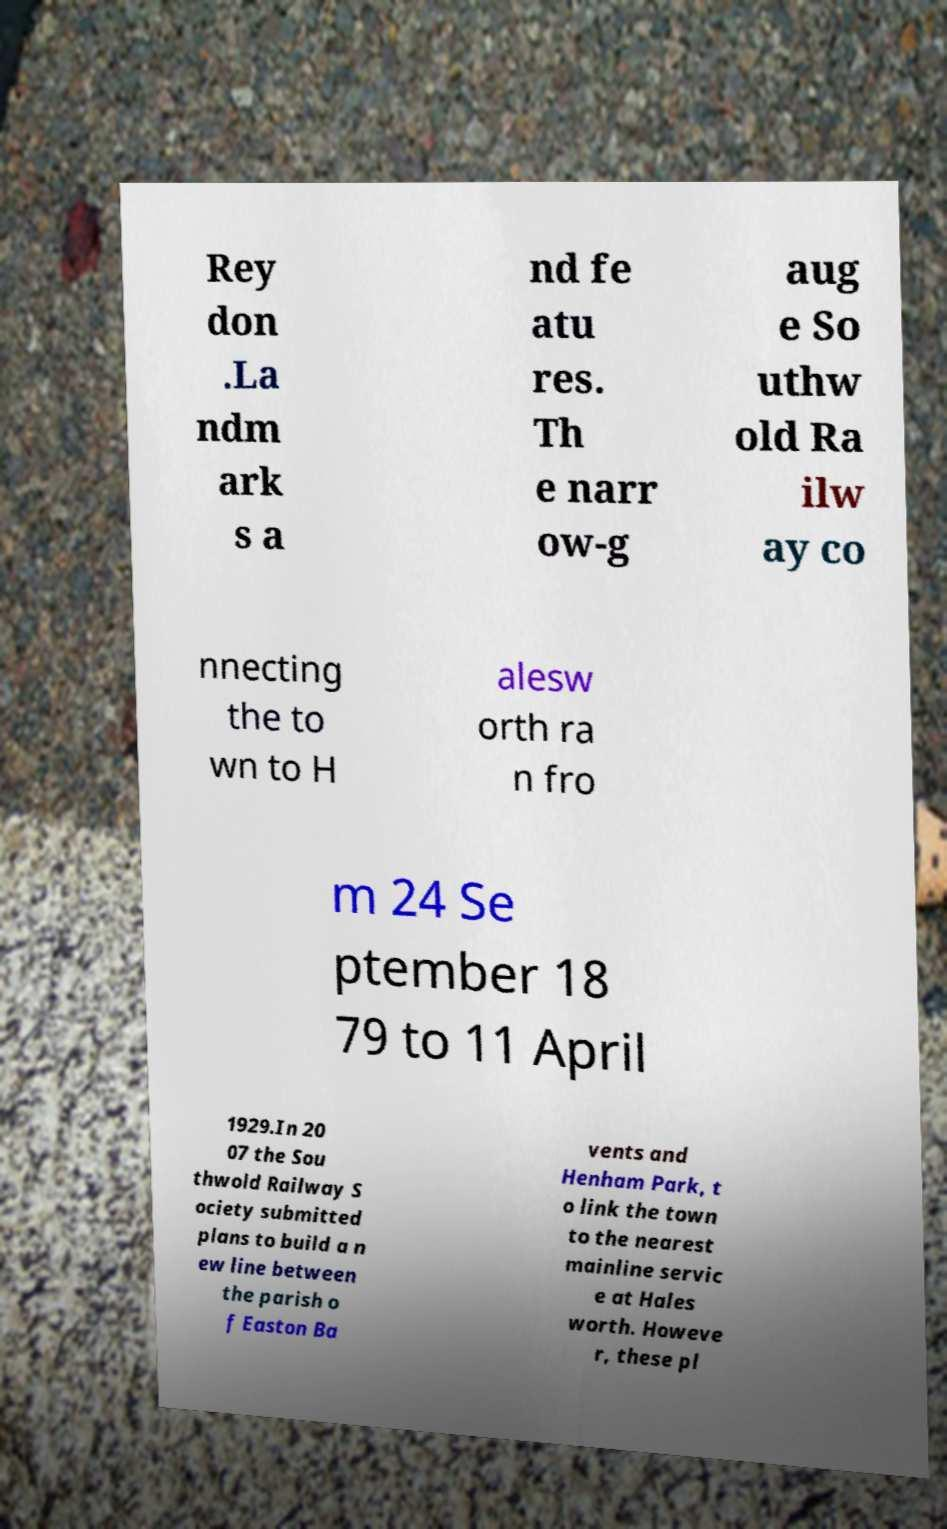Could you extract and type out the text from this image? Rey don .La ndm ark s a nd fe atu res. Th e narr ow-g aug e So uthw old Ra ilw ay co nnecting the to wn to H alesw orth ra n fro m 24 Se ptember 18 79 to 11 April 1929.In 20 07 the Sou thwold Railway S ociety submitted plans to build a n ew line between the parish o f Easton Ba vents and Henham Park, t o link the town to the nearest mainline servic e at Hales worth. Howeve r, these pl 